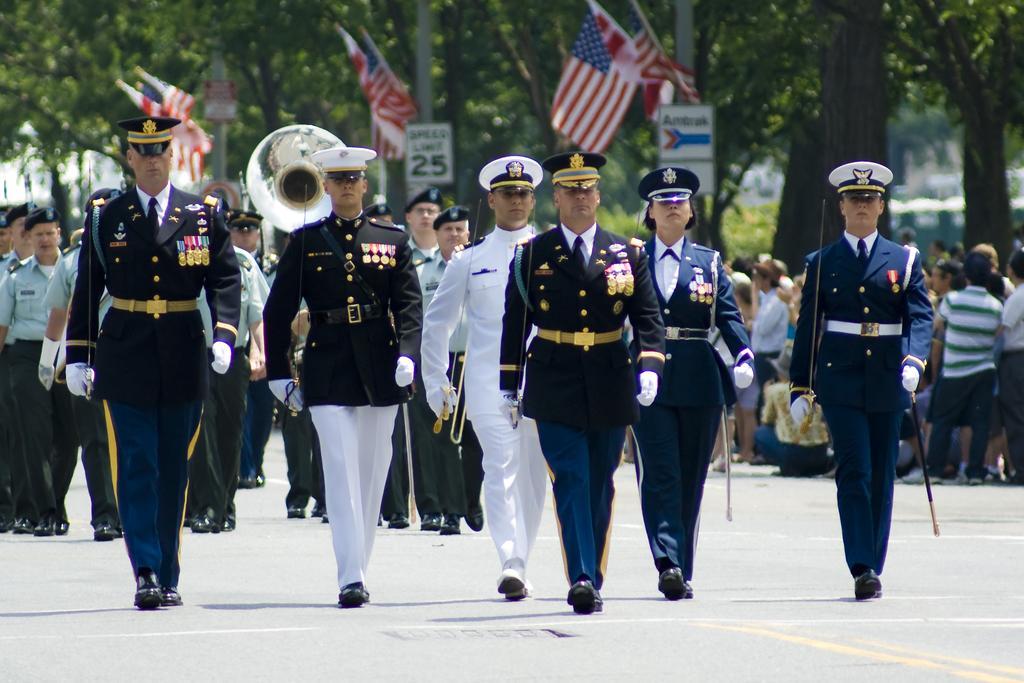Describe this image in one or two sentences. In this image I can see the ground, number of persons wearing uniforms are standing and holding few objects in their hands. In the background I can see few flags, few trees, few poles, few boards and few persons standing. I can see the blurry background. 